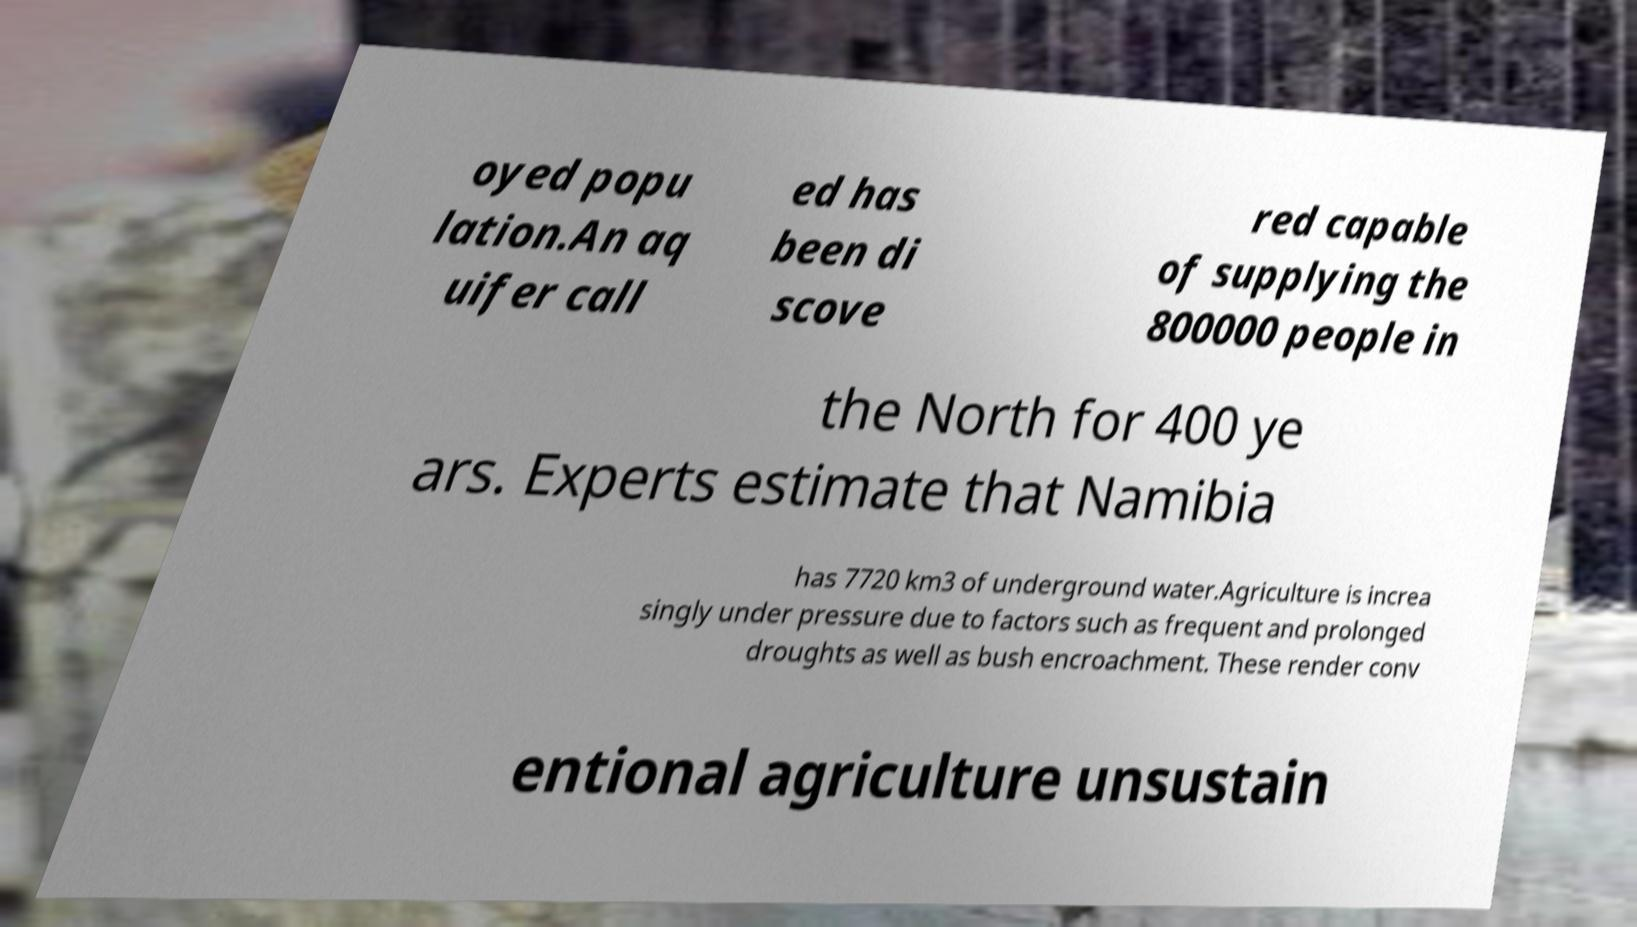Can you read and provide the text displayed in the image?This photo seems to have some interesting text. Can you extract and type it out for me? oyed popu lation.An aq uifer call ed has been di scove red capable of supplying the 800000 people in the North for 400 ye ars. Experts estimate that Namibia has 7720 km3 of underground water.Agriculture is increa singly under pressure due to factors such as frequent and prolonged droughts as well as bush encroachment. These render conv entional agriculture unsustain 